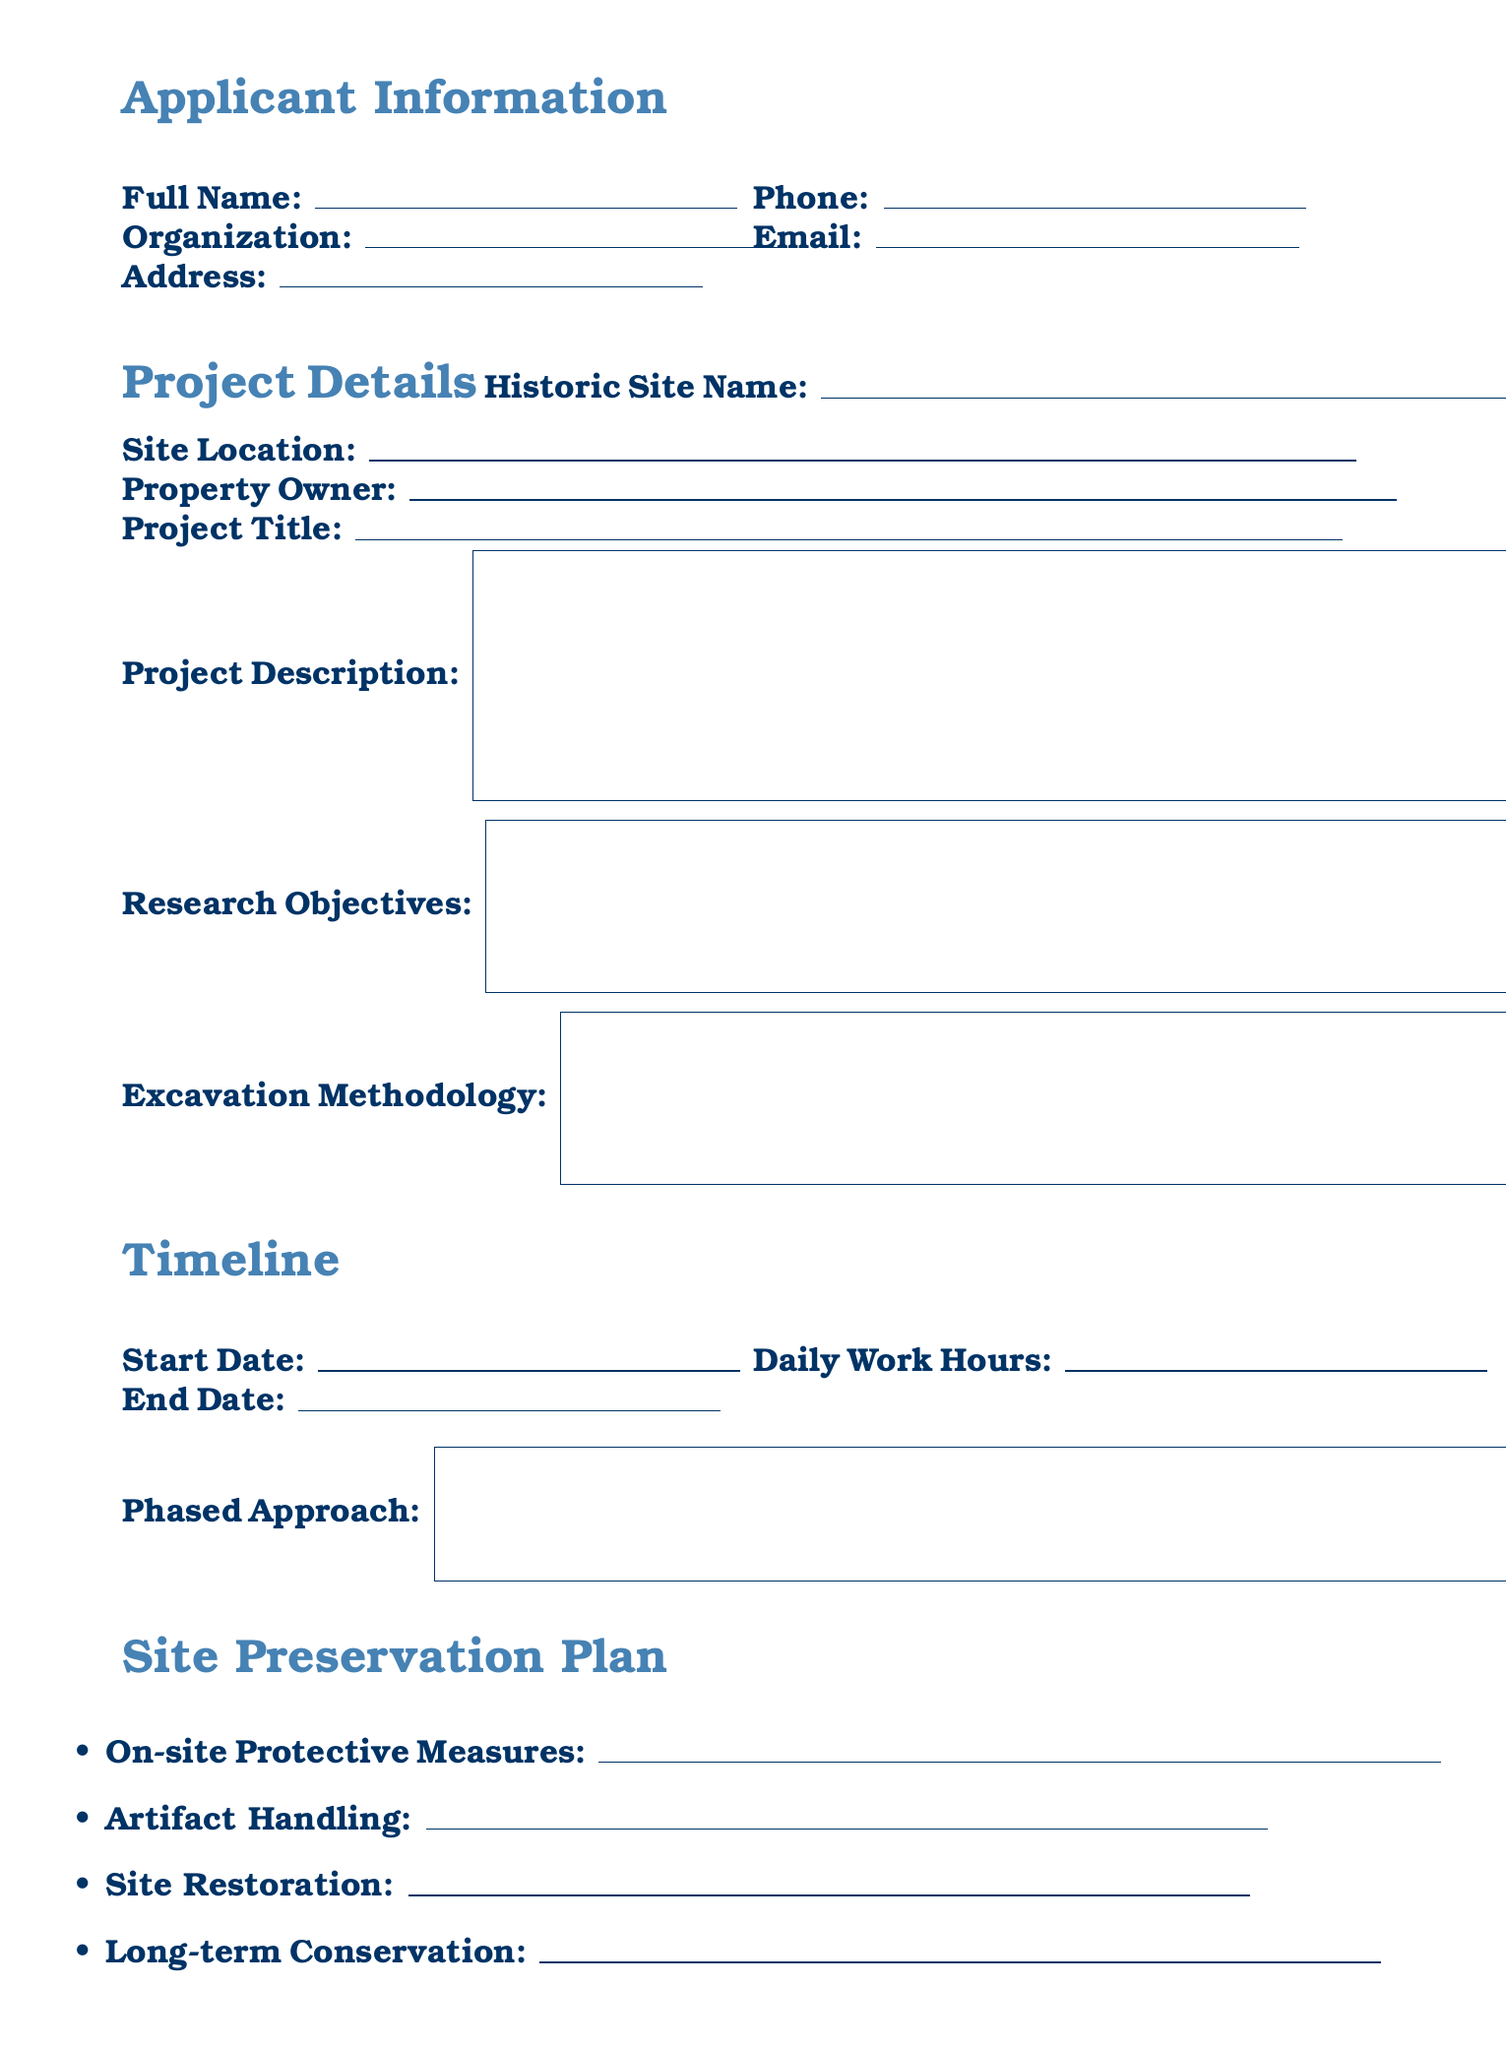What is the project title? The project title is found under the project details section of the document, specifically mentioned as "Project Title."
Answer: Project Title Who is the principal investigator? The principal investigator's name and qualifications can be found in the team composition section, which includes personnel details related to the excavation project.
Answer: Principal Investigator Name and Qualifications What are the proposed daily work hours? This information is listed under the timeline section of the document where work hours are specified for the project.
Answer: Proposed Daily Work Hours What long-term conservation strategies are proposed? This detail is included in the site preservation plan section that lists strategies for conserving the site and artifacts after the excavation is completed.
Answer: Long-term Conservation Strategies When is the estimated end date? The estimated end date is mentioned within the timeline section, indicating when the excavation work is expected to conclude.
Answer: Estimated End Date What protective measures will be taken on-site during excavation? The site preservation plan outlines measures to protect the excavation environment and artifacts during the project's execution.
Answer: On-site Protective Measures Is there a requirement for an environmental impact assessment? This question pertains to the permit requirements section, where it is indicated if an environmental impact assessment is necessary based on the project scope.
Answer: Environmental Impact Assessment How often will progress reports be submitted? The frequency of progress reports is specified in the reporting commitments section, which describes the timeline for updates on the project's progress.
Answer: Frequency of Progress Reports What funding sources are required for this project? The funding sources are detailed within the funding and sponsorship section, indicating where financial support for the project will come from.
Answer: Funding Sources 